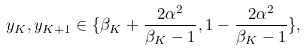Convert formula to latex. <formula><loc_0><loc_0><loc_500><loc_500>y _ { K } , y _ { K + 1 } \in \{ \beta _ { K } + \frac { 2 \alpha ^ { 2 } } { \beta _ { K } - 1 } , 1 - \frac { 2 \alpha ^ { 2 } } { \beta _ { K } - 1 } \} ,</formula> 